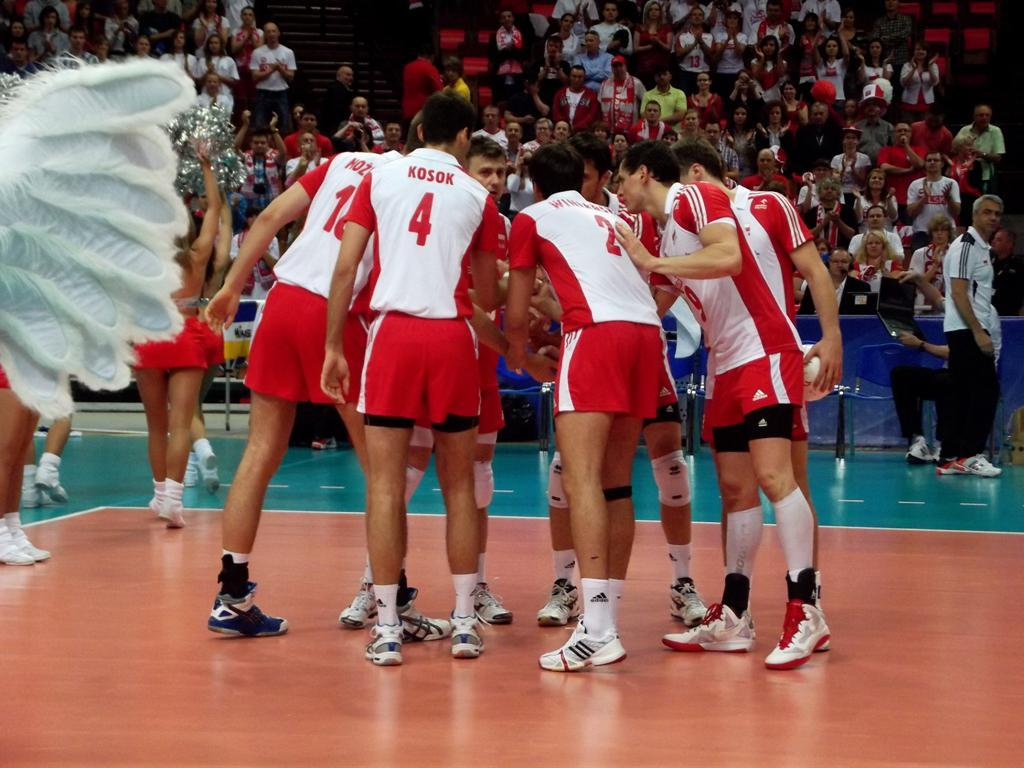<image>
Offer a succinct explanation of the picture presented. A player has a jersey on with the number four on the back. 